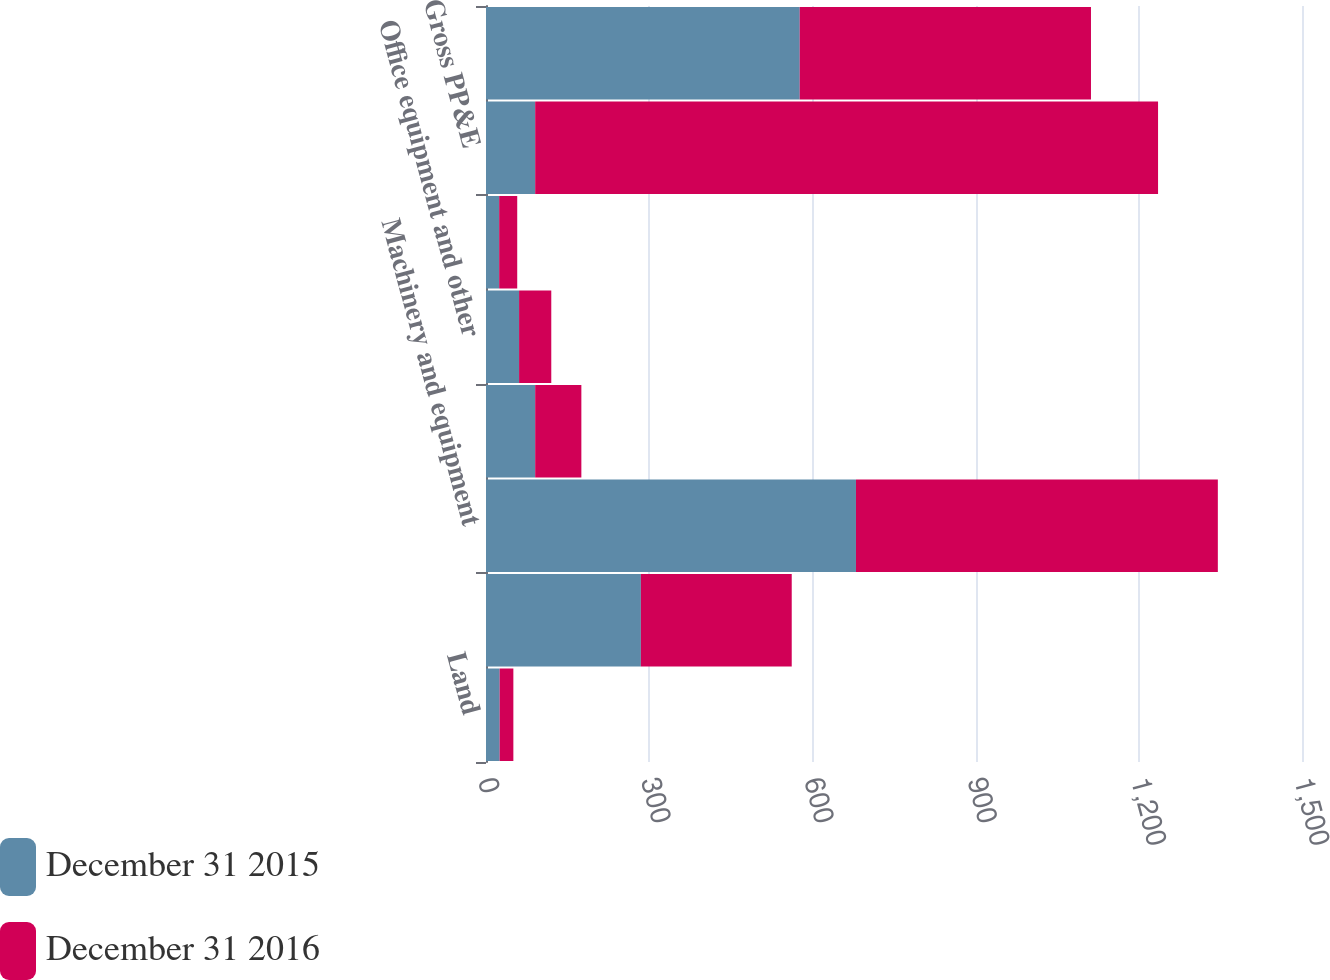Convert chart. <chart><loc_0><loc_0><loc_500><loc_500><stacked_bar_chart><ecel><fcel>Land<fcel>Buildings and improvements<fcel>Machinery and equipment<fcel>Software<fcel>Office equipment and other<fcel>Construction in progress<fcel>Gross PP&E<fcel>Less accumulated depreciation<nl><fcel>December 31 2015<fcel>25.1<fcel>284.7<fcel>680.1<fcel>90.4<fcel>60.8<fcel>24.2<fcel>90.4<fcel>576.7<nl><fcel>December 31 2016<fcel>25.2<fcel>277.3<fcel>665.2<fcel>84.9<fcel>59.2<fcel>33.2<fcel>1145<fcel>535.4<nl></chart> 